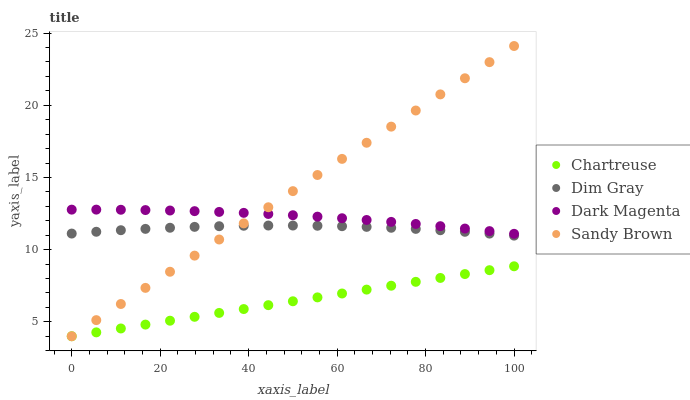Does Chartreuse have the minimum area under the curve?
Answer yes or no. Yes. Does Sandy Brown have the maximum area under the curve?
Answer yes or no. Yes. Does Dim Gray have the minimum area under the curve?
Answer yes or no. No. Does Dim Gray have the maximum area under the curve?
Answer yes or no. No. Is Chartreuse the smoothest?
Answer yes or no. Yes. Is Dim Gray the roughest?
Answer yes or no. Yes. Is Sandy Brown the smoothest?
Answer yes or no. No. Is Sandy Brown the roughest?
Answer yes or no. No. Does Chartreuse have the lowest value?
Answer yes or no. Yes. Does Dim Gray have the lowest value?
Answer yes or no. No. Does Sandy Brown have the highest value?
Answer yes or no. Yes. Does Dim Gray have the highest value?
Answer yes or no. No. Is Dim Gray less than Dark Magenta?
Answer yes or no. Yes. Is Dim Gray greater than Chartreuse?
Answer yes or no. Yes. Does Chartreuse intersect Sandy Brown?
Answer yes or no. Yes. Is Chartreuse less than Sandy Brown?
Answer yes or no. No. Is Chartreuse greater than Sandy Brown?
Answer yes or no. No. Does Dim Gray intersect Dark Magenta?
Answer yes or no. No. 